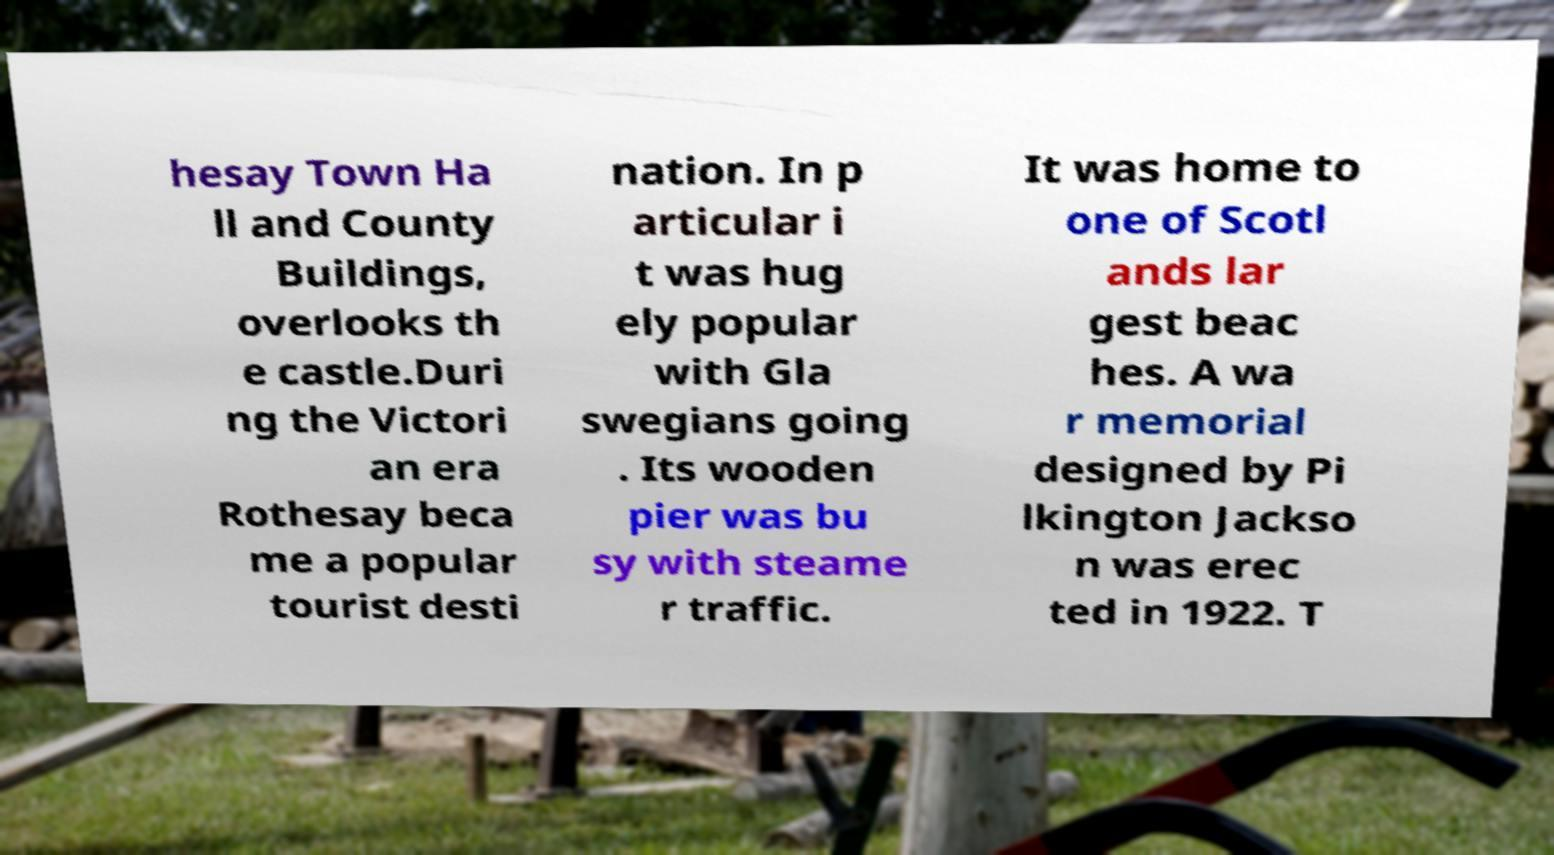Could you assist in decoding the text presented in this image and type it out clearly? hesay Town Ha ll and County Buildings, overlooks th e castle.Duri ng the Victori an era Rothesay beca me a popular tourist desti nation. In p articular i t was hug ely popular with Gla swegians going . Its wooden pier was bu sy with steame r traffic. It was home to one of Scotl ands lar gest beac hes. A wa r memorial designed by Pi lkington Jackso n was erec ted in 1922. T 